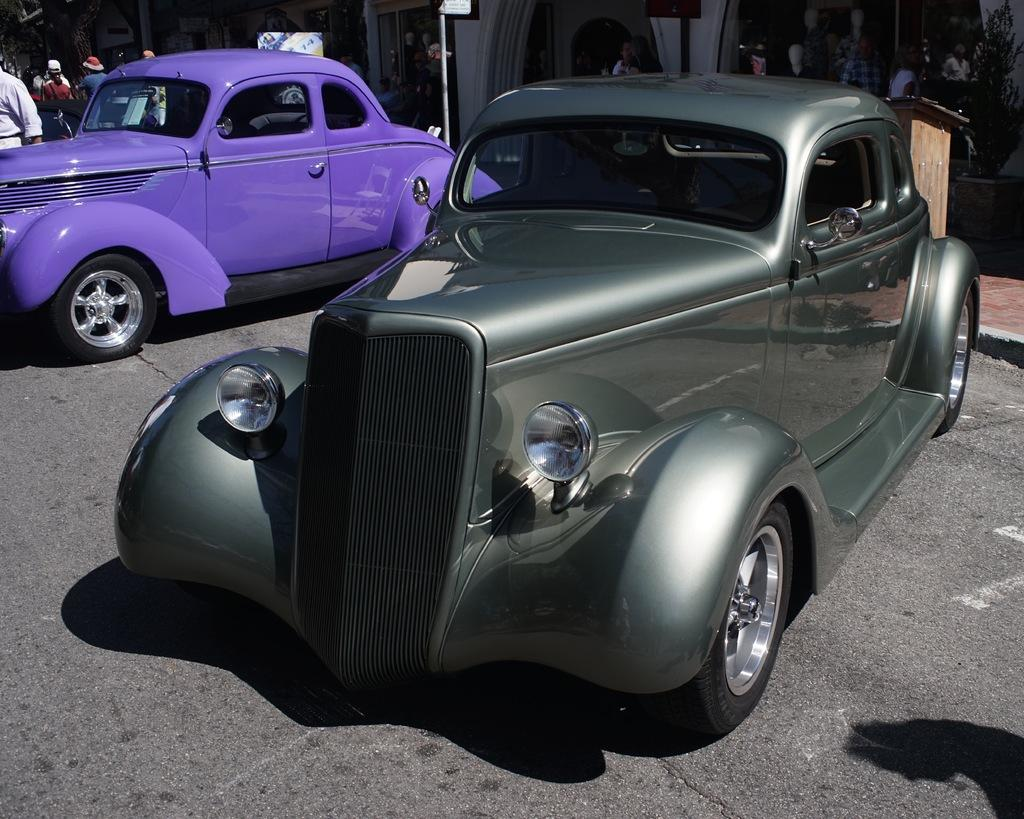What can be seen on the road in the image? There are two cars parked on the road. What are the people near the cars doing? People are standing beside the cars. What can be seen in the background of the image? There are buildings visible at the back side of the image. Are there any fairies flying around the cars in the image? There are no fairies present in the image. What season is it in the image, given the presence of spring flowers? There is no indication of a specific season in the image, as no flowers or other seasonal elements are mentioned. 